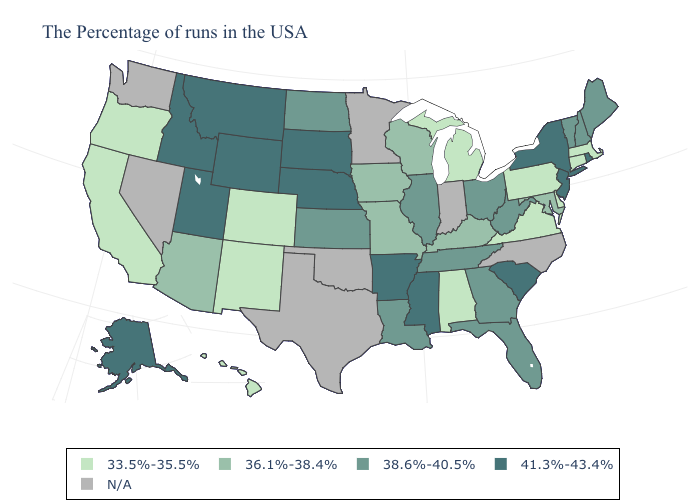Is the legend a continuous bar?
Keep it brief. No. What is the value of Maryland?
Write a very short answer. 36.1%-38.4%. Does Alaska have the lowest value in the USA?
Be succinct. No. Name the states that have a value in the range 41.3%-43.4%?
Short answer required. Rhode Island, New York, New Jersey, South Carolina, Mississippi, Arkansas, Nebraska, South Dakota, Wyoming, Utah, Montana, Idaho, Alaska. What is the lowest value in the MidWest?
Quick response, please. 33.5%-35.5%. What is the value of New Hampshire?
Be succinct. 38.6%-40.5%. Does the map have missing data?
Concise answer only. Yes. Does Utah have the highest value in the West?
Answer briefly. Yes. Name the states that have a value in the range 33.5%-35.5%?
Be succinct. Massachusetts, Connecticut, Delaware, Pennsylvania, Virginia, Michigan, Alabama, Colorado, New Mexico, California, Oregon, Hawaii. Name the states that have a value in the range 38.6%-40.5%?
Concise answer only. Maine, New Hampshire, Vermont, West Virginia, Ohio, Florida, Georgia, Tennessee, Illinois, Louisiana, Kansas, North Dakota. Name the states that have a value in the range 36.1%-38.4%?
Be succinct. Maryland, Kentucky, Wisconsin, Missouri, Iowa, Arizona. Does Montana have the highest value in the West?
Answer briefly. Yes. Is the legend a continuous bar?
Keep it brief. No. What is the lowest value in the West?
Short answer required. 33.5%-35.5%. 